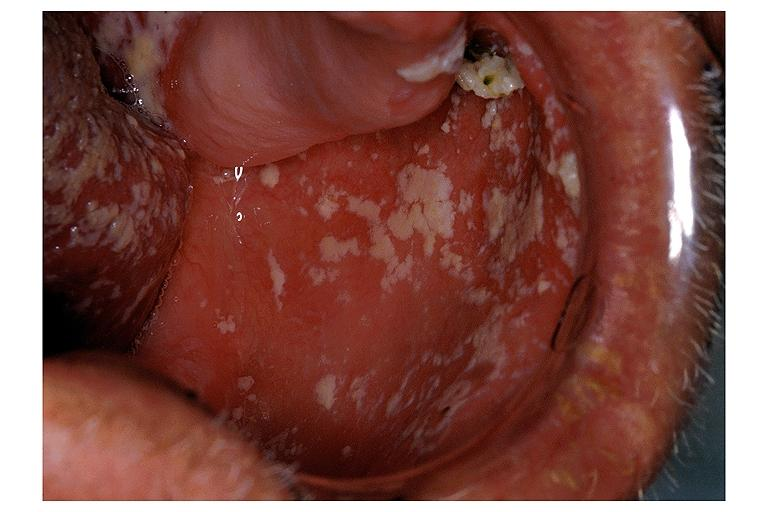what is present?
Answer the question using a single word or phrase. Oral 